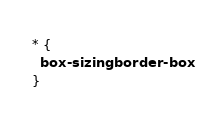<code> <loc_0><loc_0><loc_500><loc_500><_CSS_>* {
  box-sizing: border-box
}
</code> 